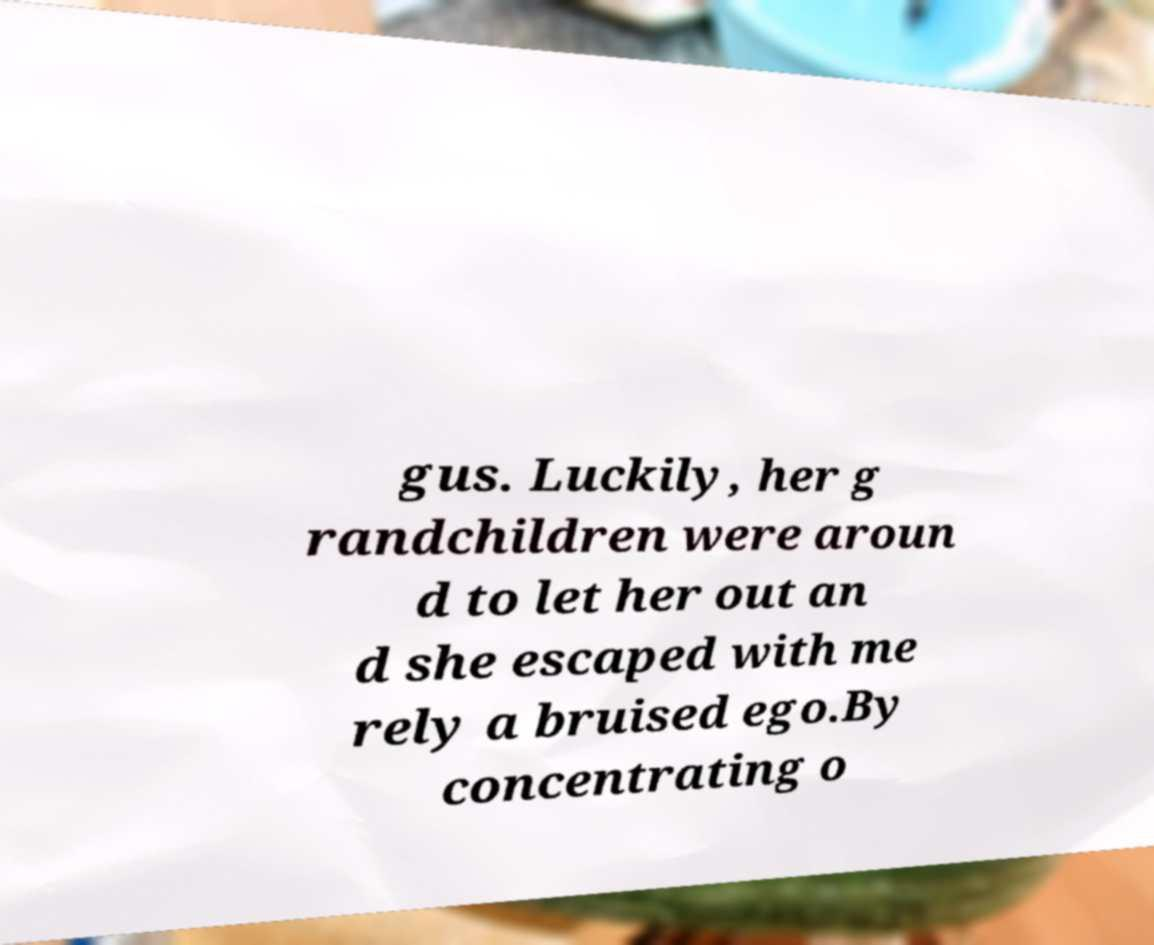Can you read and provide the text displayed in the image?This photo seems to have some interesting text. Can you extract and type it out for me? gus. Luckily, her g randchildren were aroun d to let her out an d she escaped with me rely a bruised ego.By concentrating o 